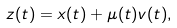<formula> <loc_0><loc_0><loc_500><loc_500>z ( t ) = x ( t ) + \mu ( t ) v ( t ) ,</formula> 